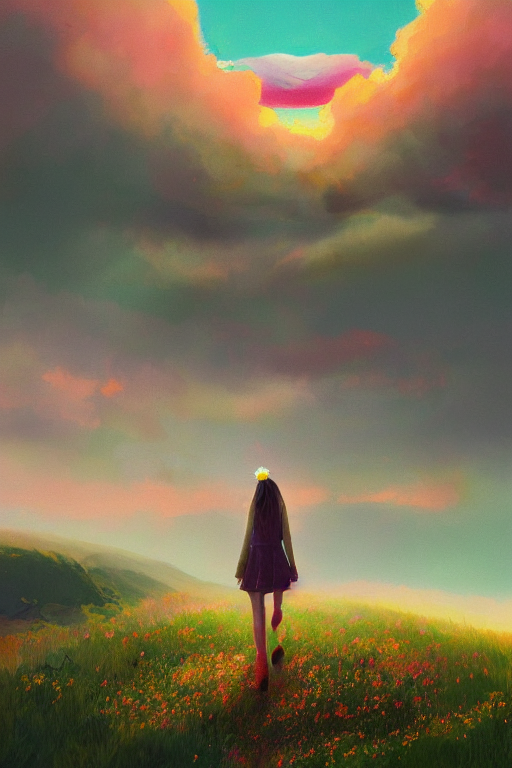Are the colors rich? Indeed, the colors in the image are quite rich and vivid. The sky presents a dynamic range of hues from warm oranges and pinks to cooler purples and blues, providing a striking contrast that complements the lush greenery of the grass field. Little pops of color from the flowers offer a sense of diversity and vibrancy to the scene. 